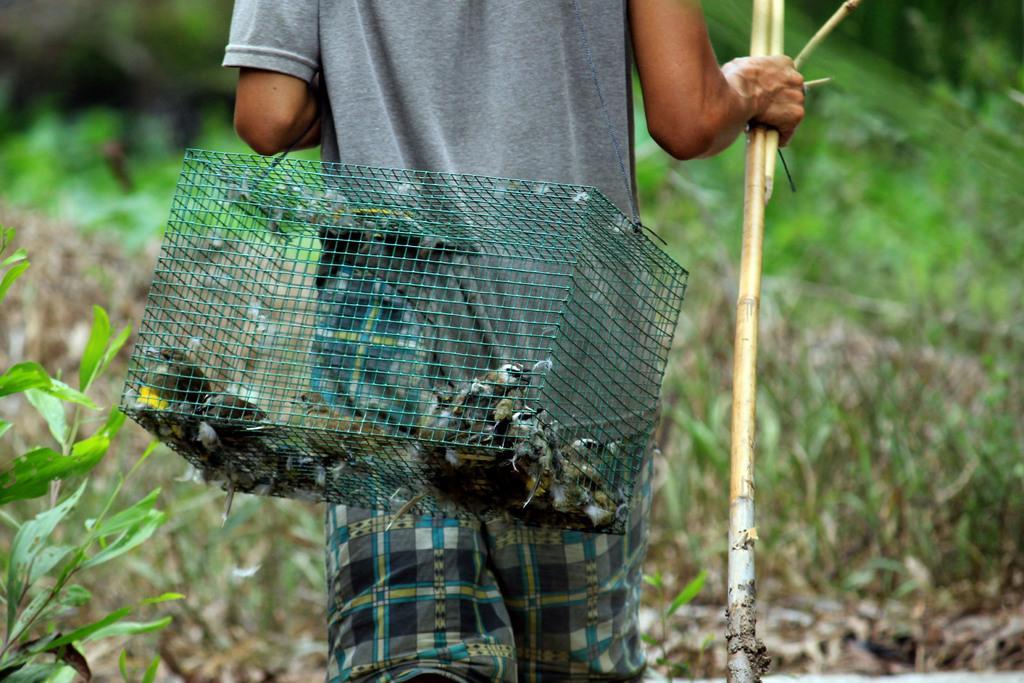In one or two sentences, can you explain what this image depicts? In this picture we can see a person holding a wooden stick, is carrying a cage. We can see birds in the cage. Background portion of the picture is blur. We can see green leaves. 